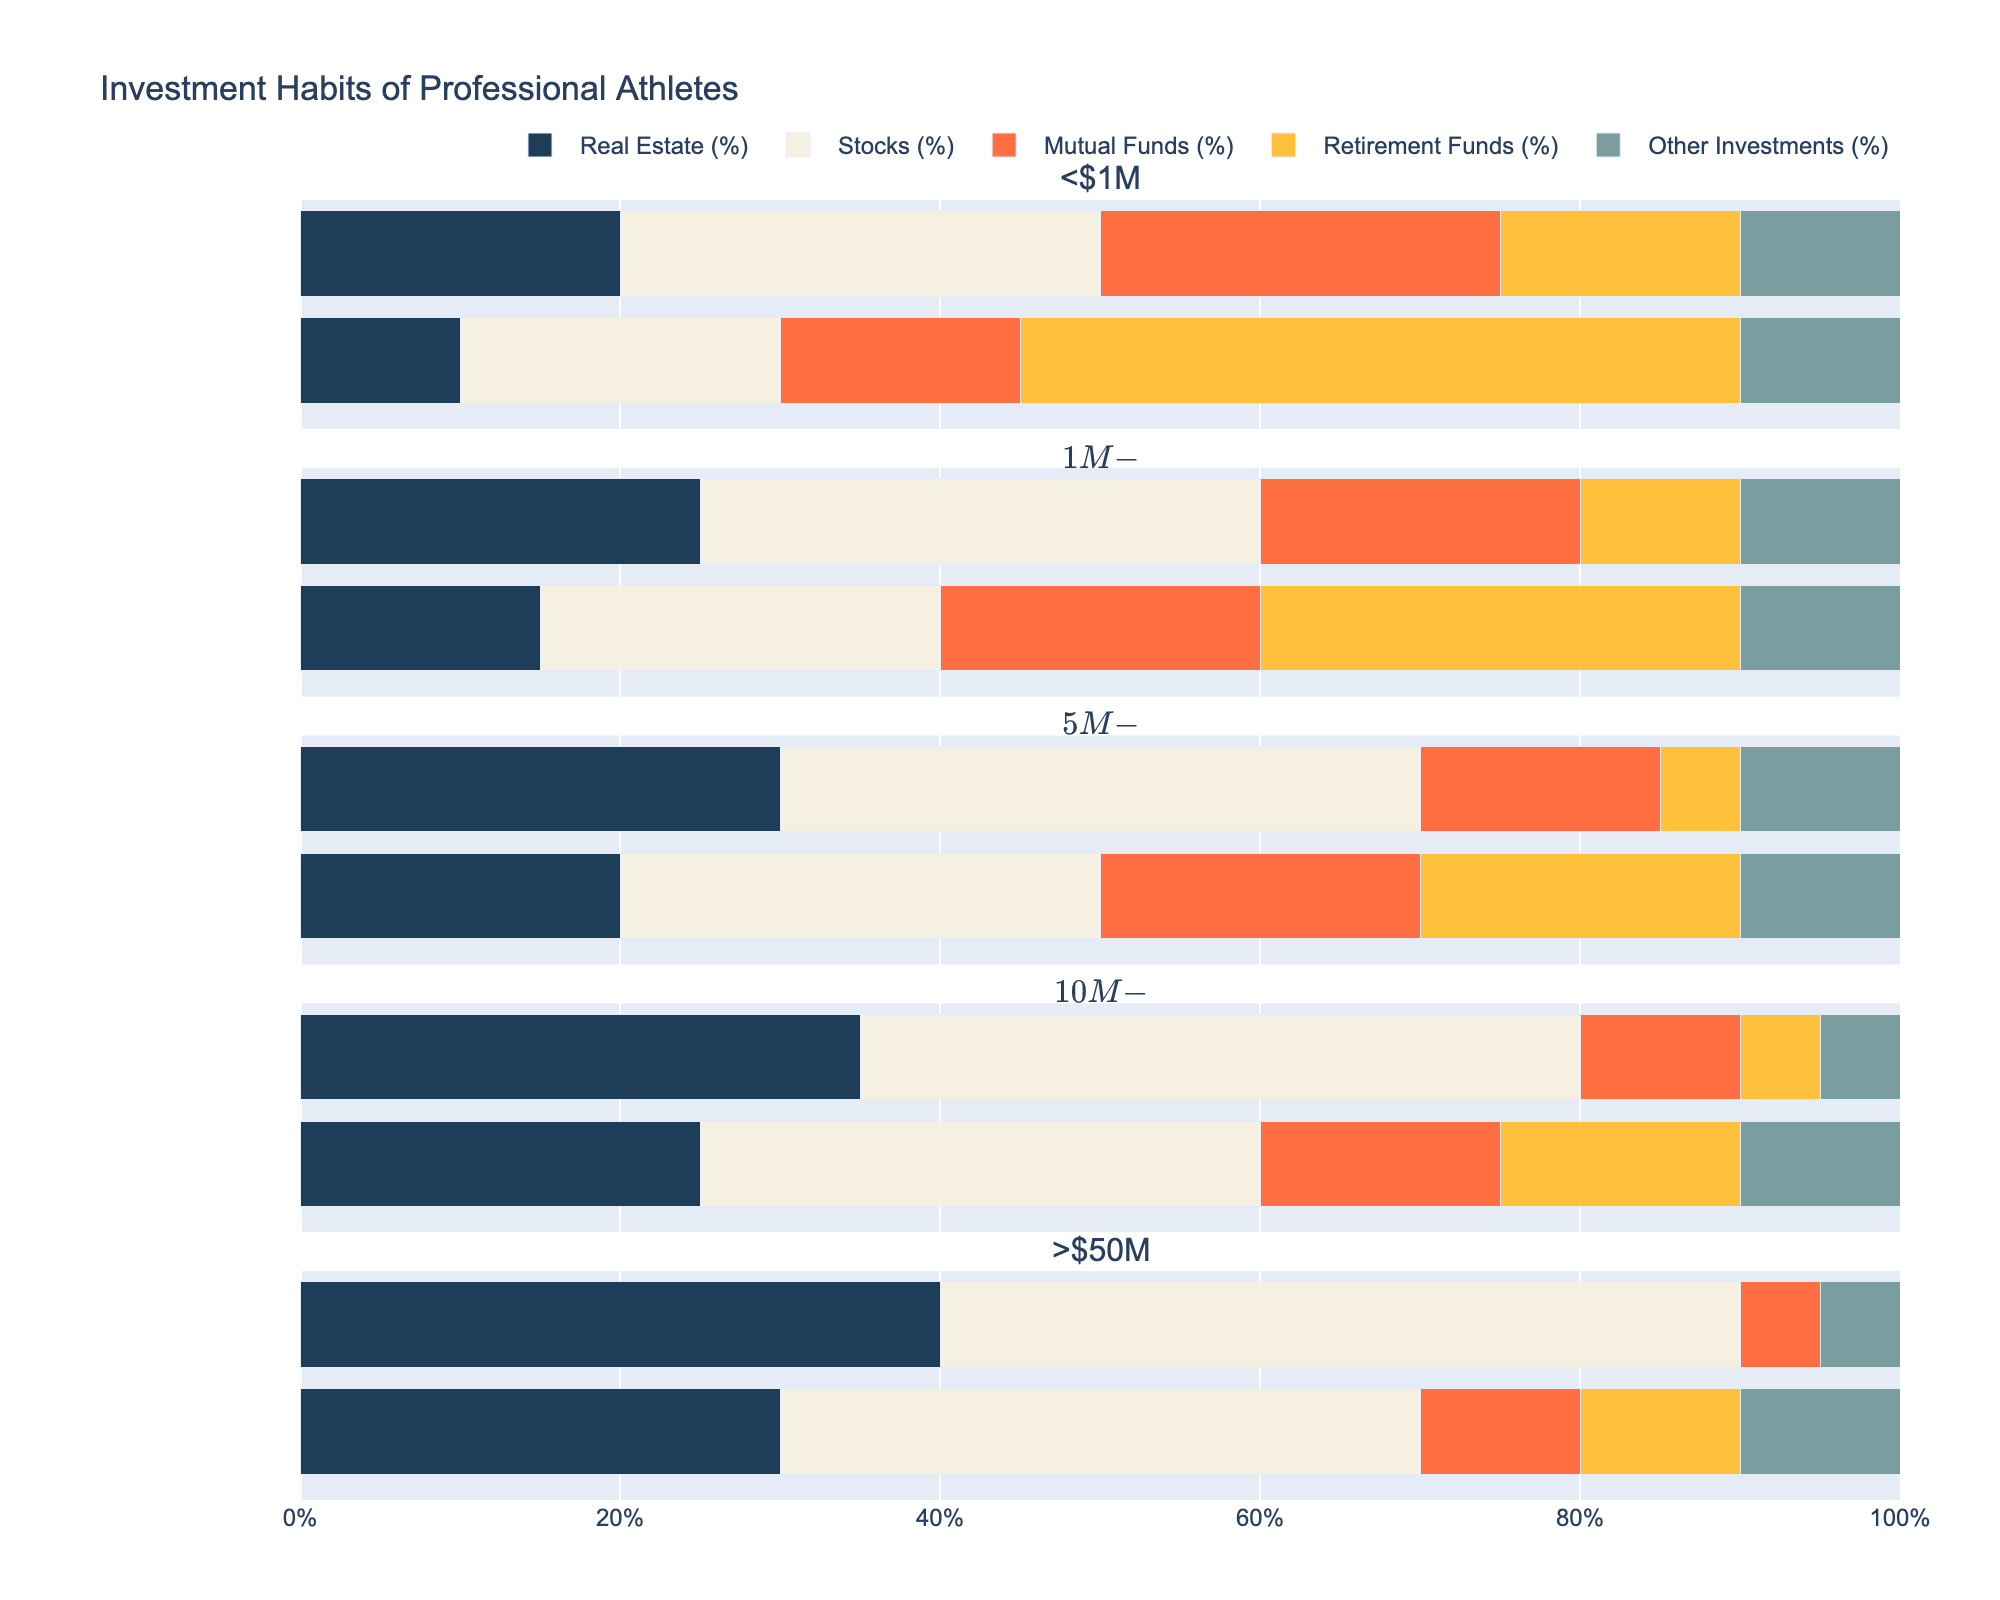Which earnings bracket shows the highest percentage of investments in Real Estate for athletes with financial advisors? Look at the bars under 'With Advisor' for Real Estate percentage across all earnings brackets. The $50M+ bracket has the longest bar.
Answer: >$50M How does the percentage of Retirement Funds compare for athletes earning between $10M-$50M with and without advisors? Compare the height of the Retirement Funds bar in the '$10M-$50M' row for both 'No Advisor' and 'With Advisor'. 'No Advisor' has 15%, and 'With Advisor' has 5%.
Answer: 'No Advisor' has 10% more What is the difference in the percentage allocation to Stocks between the highest and lowest earnings brackets for athletes with financial advisors? Find the bar lengths for Stocks in '>50M' and '<$1M' under 'With Advisor'. '>50M' is 50%, and '<$1M' is 30%.
Answer: 20% What investment category sees the least change in percentage allocation between athletes with and without advisors in the $1M-$5M earnings bracket? Calculate the difference in bar lengths for each category in the '$1M-$5M' row. 'Mutual Funds' remains at 20%.
Answer: Mutual Funds If we average the percentage allocation in Real Estate for athletes with financial advisors across all earnings brackets, what is the average? Add Real Estate percentages for 'With Advisor' across all brackets and divide by the number of brackets. (20+25+30+35+40)/5 = 30%
Answer: 30% In which earnings bracket does having a financial advisor make the biggest difference in Mutual Funds allocation? Calculate the difference in Mutual Funds bar lengths between 'No Advisor' and 'With Advisor' for each bracket. The '<$1M' bracket has the biggest difference from 15% (No Advisor) to 25% (With Advisor).
Answer: <$1M For athletes earning $5M-$10M, what percentage of investments is not in Real Estate, Stocks, or Mutual Funds when they have a financial advisor? Sum the percentages for categories other than Real Estate, Stocks, and Mutual Funds for '$5M-$10M' 'With Advisor'. (5% + 10%) = 15%
Answer: 15% Comparing the $10M-$50M and >$50M brackets, which category has the largest increase in percentage allocation for athletes with financial advisors? For each category, find the difference between percentages in '$10M-$50M' and '>50M' rows under 'With Advisor'. Stocks show the highest increase from 45% to 50%.
Answer: Stocks 